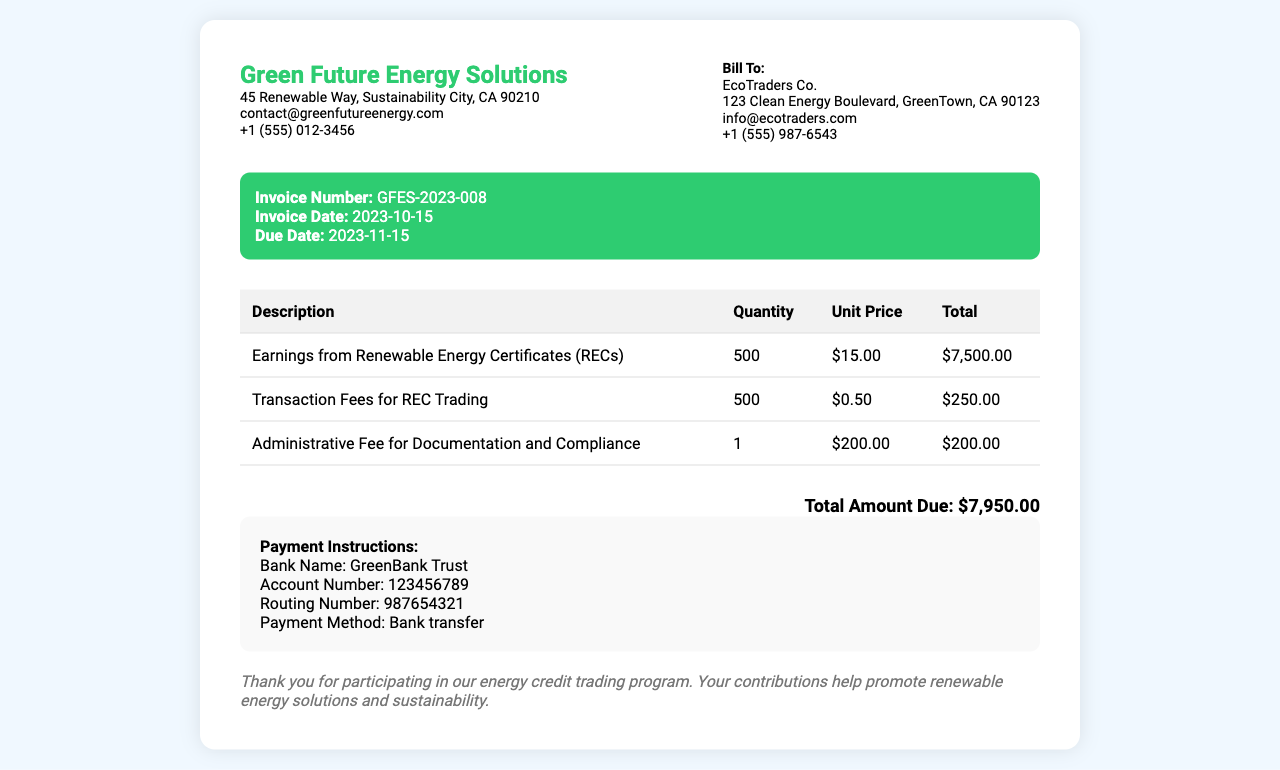What is the invoice number? The invoice number is listed in the document under invoice details as GFES-2023-008.
Answer: GFES-2023-008 What is the due date for this invoice? The due date is specified in the invoice details section as 2023-11-15.
Answer: 2023-11-15 How much is the total amount due? The total amount due is located at the bottom of the invoice and is $7,950.00.
Answer: $7,950.00 What is the unit price for the earnings from Renewable Energy Certificates? The unit price for the earnings from RECs is stated in the table as $15.00.
Answer: $15.00 What is the quantity of transaction fees charged? The quantity for transaction fees is mentioned as 500 in the table under quantity.
Answer: 500 What is the purpose of the administrative fee listed? The administrative fee is described as being for documentation and compliance in the table.
Answer: Documentation and Compliance How many Renewable Energy Certificates were issued? The quantity of Renewable Energy Certificates is shown in the table as 500.
Answer: 500 Who is the client receiving the invoice? The client information section indicates that EcoTraders Co. is the recipient of the invoice.
Answer: EcoTraders Co What is the payment method specified in the document? The payment method is detailed in the payment instructions as bank transfer.
Answer: Bank transfer 